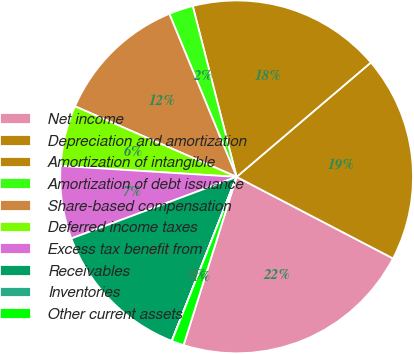Convert chart. <chart><loc_0><loc_0><loc_500><loc_500><pie_chart><fcel>Net income<fcel>Depreciation and amortization<fcel>Amortization of intangible<fcel>Amortization of debt issuance<fcel>Share-based compensation<fcel>Deferred income taxes<fcel>Excess tax benefit from<fcel>Receivables<fcel>Inventories<fcel>Other current assets<nl><fcel>22.21%<fcel>18.88%<fcel>17.77%<fcel>2.23%<fcel>12.22%<fcel>5.56%<fcel>6.67%<fcel>13.33%<fcel>0.01%<fcel>1.12%<nl></chart> 